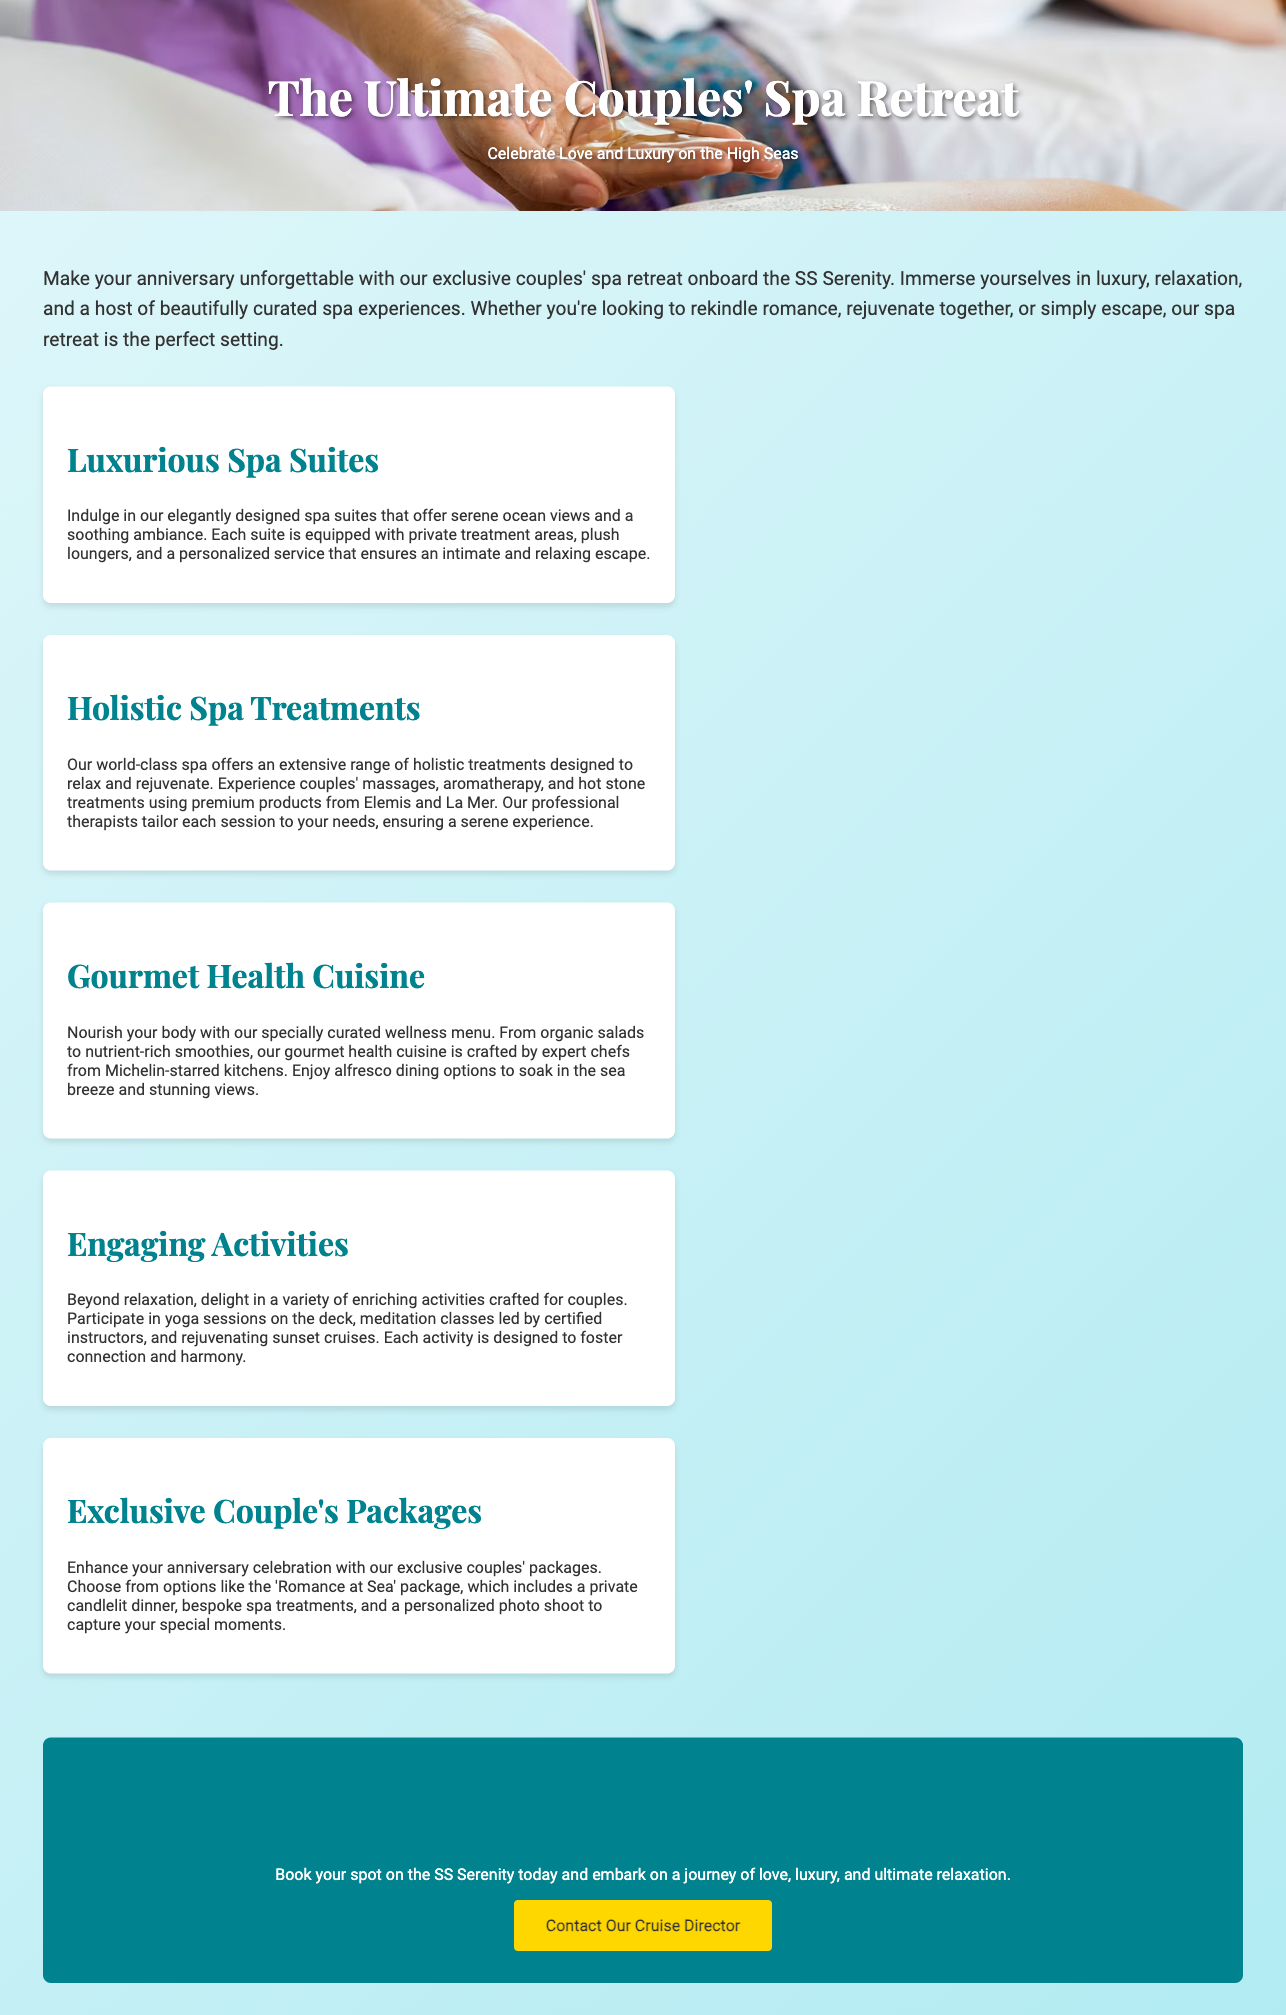What is the name of the cruise ship? The document mentions the cruise ship's name as SS Serenity.
Answer: SS Serenity What type of cuisine is offered? The advertisement specifies that gourmet health cuisine is part of the retreat.
Answer: Gourmet health cuisine What kind of treatments are featured in the spa? The document lists holistic spa treatments, including massages and aromatherapy.
Answer: Holistic spa treatments How many sections are there in the activities? The document includes five sections related to different aspects of the couples' retreat.
Answer: Five What is included in the 'Romance at Sea' package? The document states that this package includes a private candlelit dinner and bespoke spa treatments.
Answer: Private candlelit dinner and bespoke spa treatments What is the purpose of the retreat? The advertisement emphasizes that the retreat is meant to celebrate love and luxury.
Answer: Celebrate love and luxury What activity is offered for connection? The document mentions engaging in yoga sessions on the deck.
Answer: Yoga sessions What is the call to action? The advertisement encourages readers to book their spot and contact the cruise director.
Answer: Contact our cruise director 